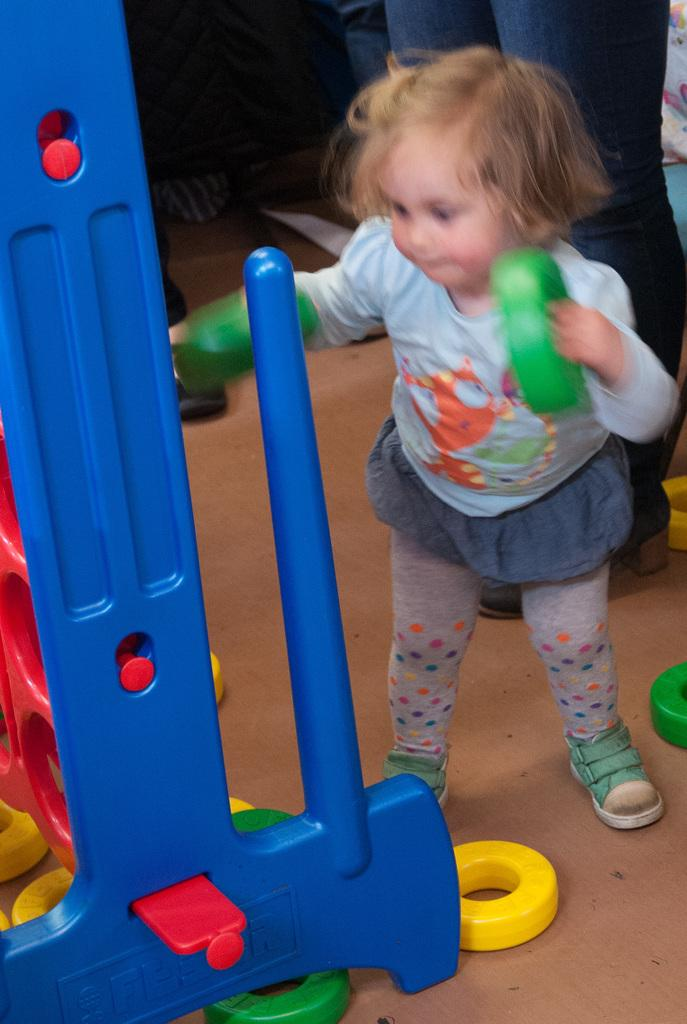Who is the main subject in the image? There is a small girl in the image. What is the girl doing in the image? The girl is playing with rings. What color is the stand in the image? The stand in the image is blue. What can be seen in the background of the image? There are many people in the background of the image. How many lizards can be seen crawling on the stand in the image? There are no lizards present in the image. Is there a trail leading to the girl in the image? There is no trail visible in the image. 